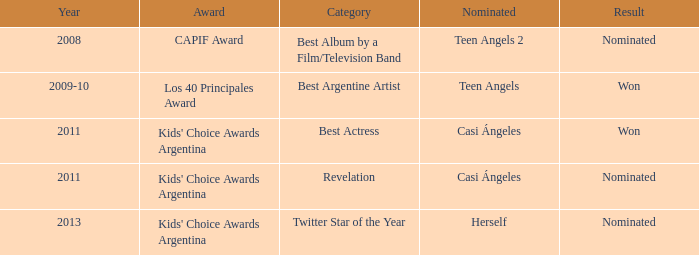Specify the performance that received a capif award nomination. Teen Angels 2. 